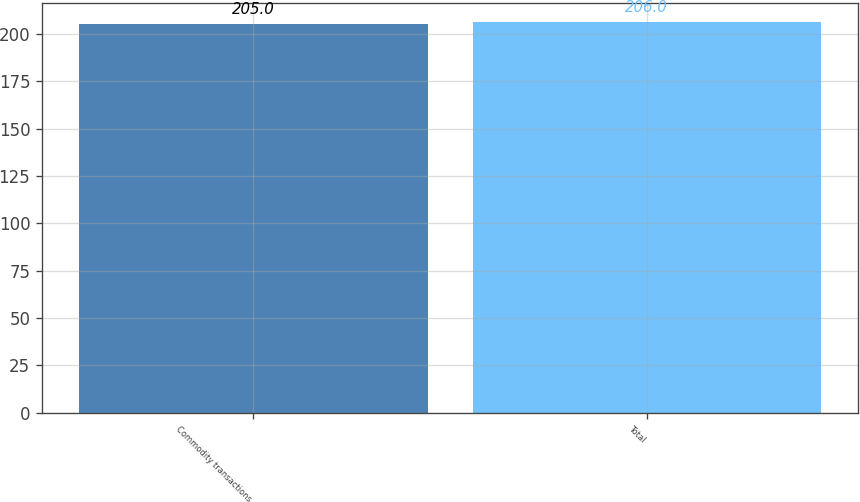<chart> <loc_0><loc_0><loc_500><loc_500><bar_chart><fcel>Commodity transactions<fcel>Total<nl><fcel>205<fcel>206<nl></chart> 